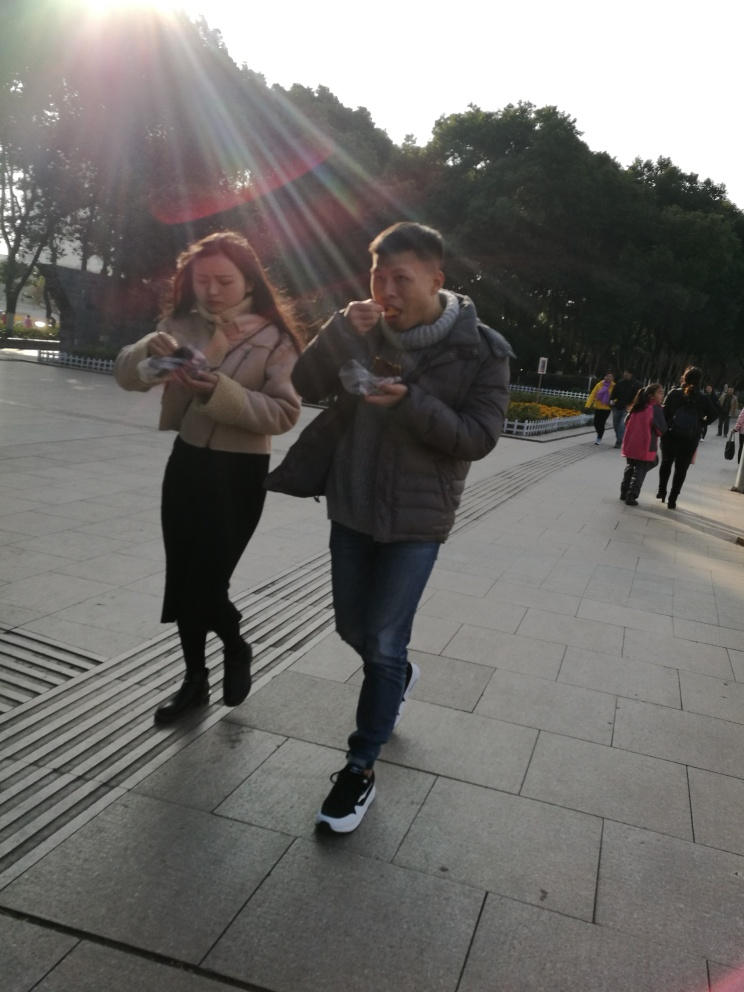Can you describe the setting of this image? The setting is an urban outdoor area with walkways and a line of trees in the background. The attire of the individuals suggests it is a cold day. Pedestrians in the background also suggest a public space, likely a park or a plaza. 